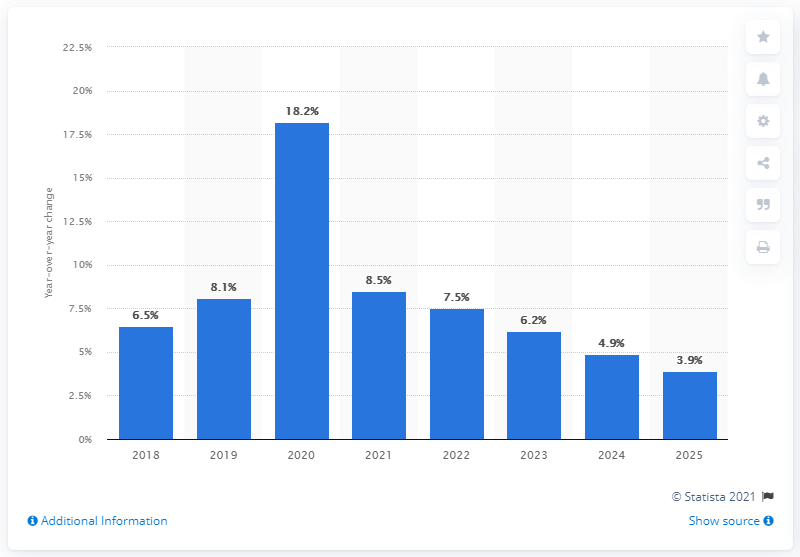Outline some significant characteristics in this image. The forecasted growth rate for retail e-commerce sales in 2025 is expected to be 3.9%. 